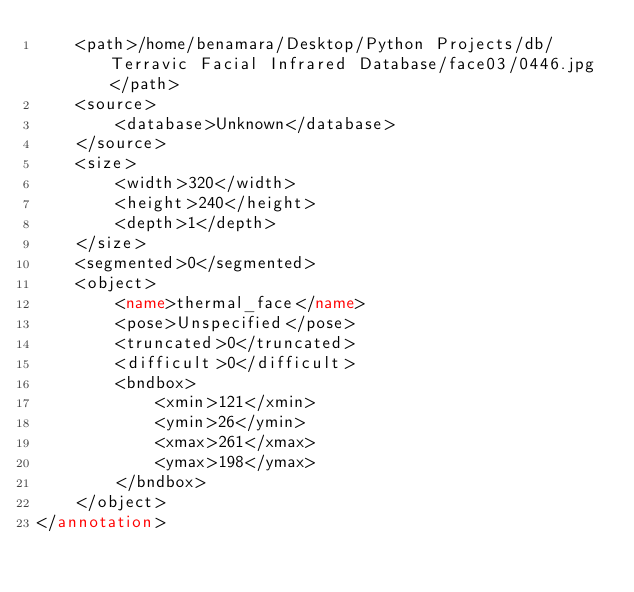Convert code to text. <code><loc_0><loc_0><loc_500><loc_500><_XML_>	<path>/home/benamara/Desktop/Python Projects/db/Terravic Facial Infrared Database/face03/0446.jpg</path>
	<source>
		<database>Unknown</database>
	</source>
	<size>
		<width>320</width>
		<height>240</height>
		<depth>1</depth>
	</size>
	<segmented>0</segmented>
	<object>
		<name>thermal_face</name>
		<pose>Unspecified</pose>
		<truncated>0</truncated>
		<difficult>0</difficult>
		<bndbox>
			<xmin>121</xmin>
			<ymin>26</ymin>
			<xmax>261</xmax>
			<ymax>198</ymax>
		</bndbox>
	</object>
</annotation>
</code> 